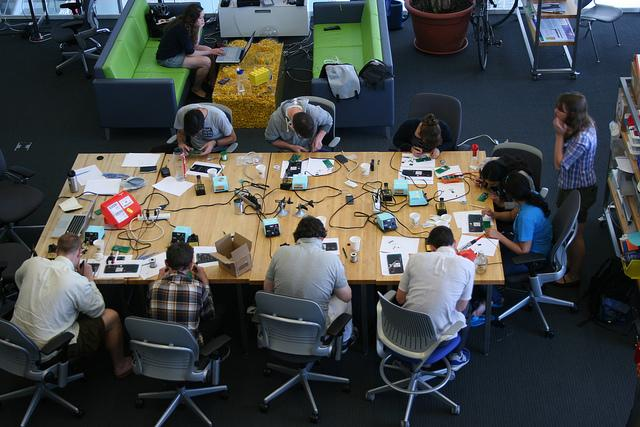What would soon stop here if there were a power outage? Please explain your reasoning. all work. The people working are dependent on the electricity and cords. 